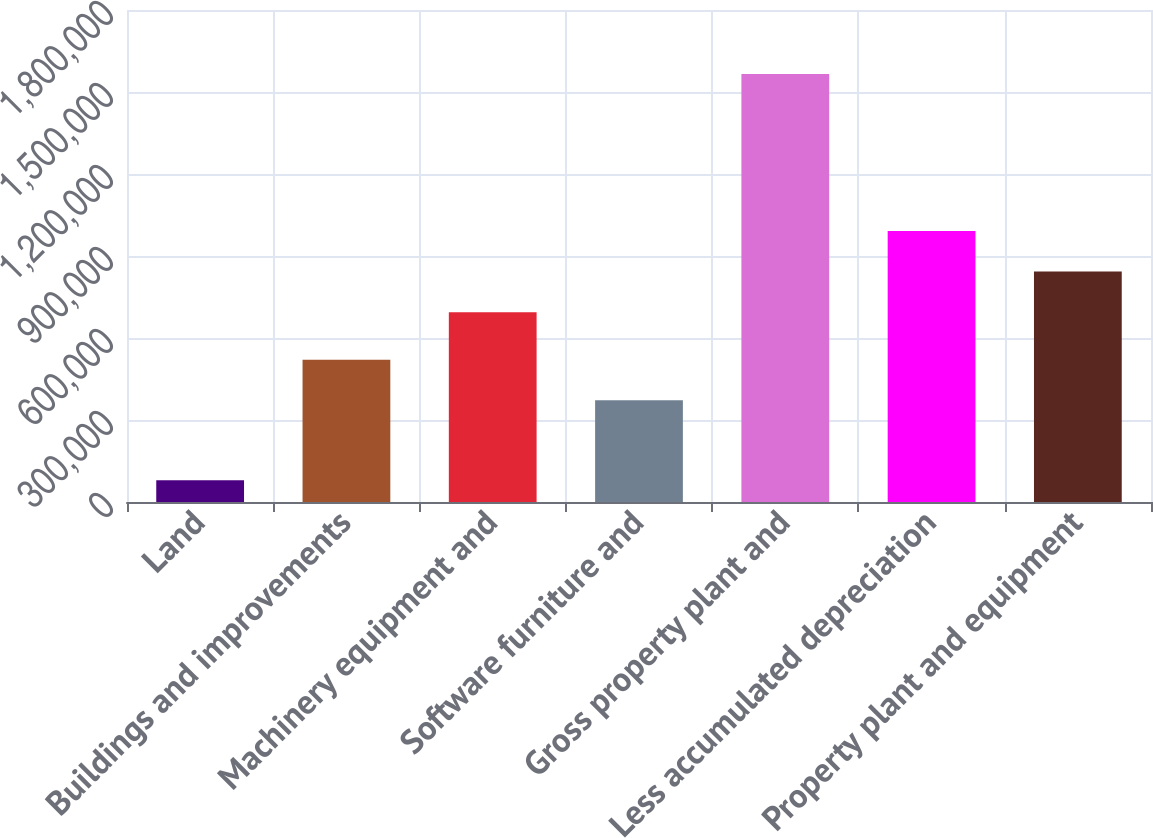Convert chart to OTSL. <chart><loc_0><loc_0><loc_500><loc_500><bar_chart><fcel>Land<fcel>Buildings and improvements<fcel>Machinery equipment and<fcel>Software furniture and<fcel>Gross property plant and<fcel>Less accumulated depreciation<fcel>Property plant and equipment<nl><fcel>79557<fcel>520712<fcel>694179<fcel>372052<fcel>1.56615e+06<fcel>991498<fcel>842838<nl></chart> 